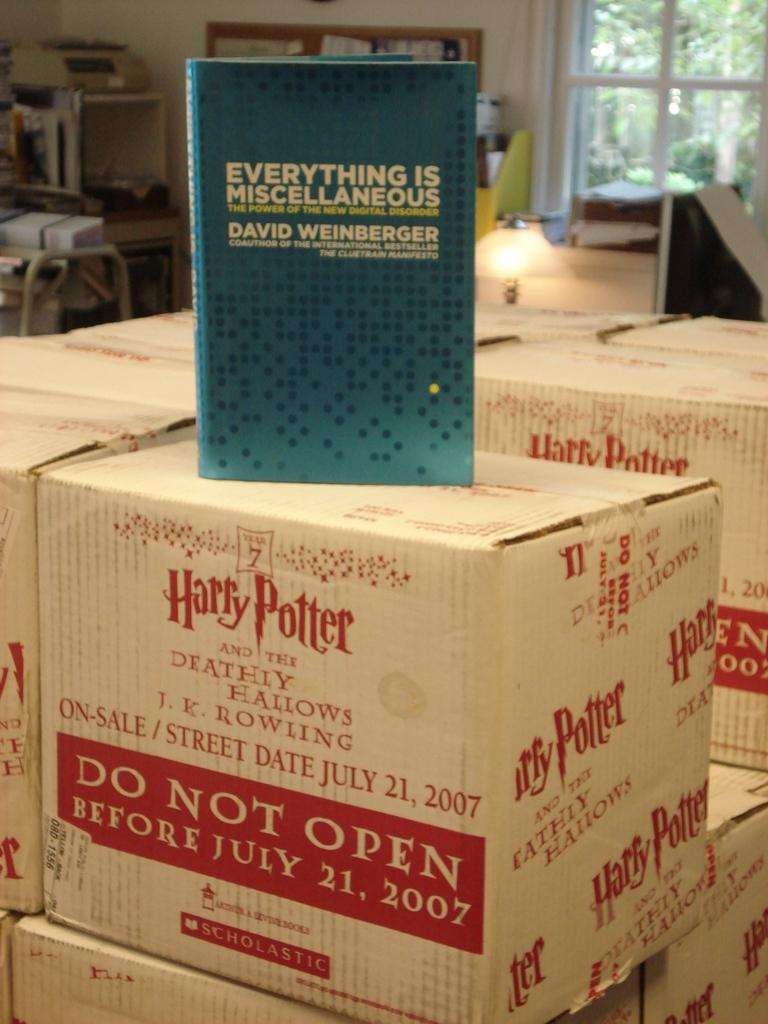<image>
Describe the image concisely. Stacks of white boxes containing the book Harry Potter and the Deathly Hallows. 